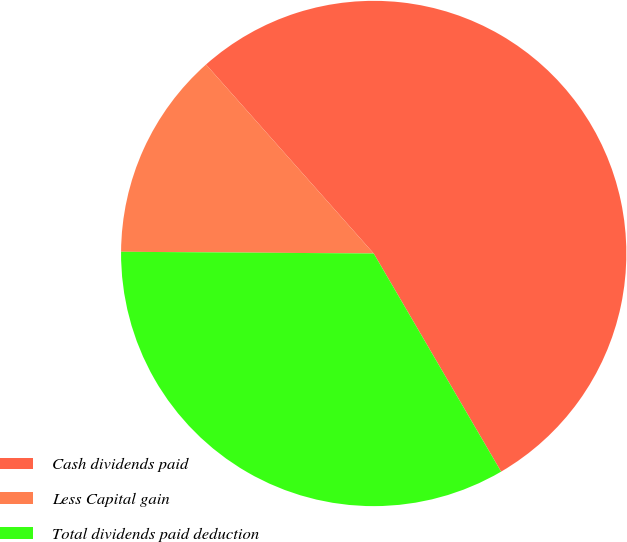Convert chart. <chart><loc_0><loc_0><loc_500><loc_500><pie_chart><fcel>Cash dividends paid<fcel>Less Capital gain<fcel>Total dividends paid deduction<nl><fcel>53.14%<fcel>13.34%<fcel>33.52%<nl></chart> 